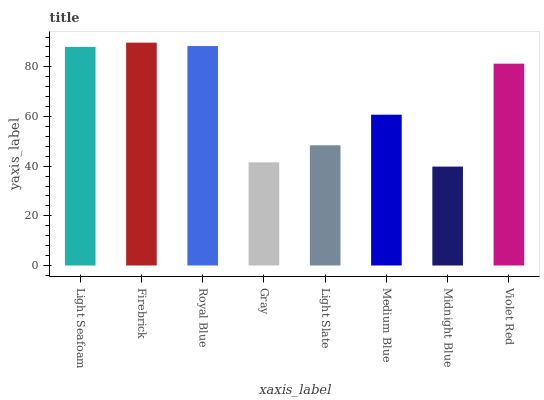Is Midnight Blue the minimum?
Answer yes or no. Yes. Is Firebrick the maximum?
Answer yes or no. Yes. Is Royal Blue the minimum?
Answer yes or no. No. Is Royal Blue the maximum?
Answer yes or no. No. Is Firebrick greater than Royal Blue?
Answer yes or no. Yes. Is Royal Blue less than Firebrick?
Answer yes or no. Yes. Is Royal Blue greater than Firebrick?
Answer yes or no. No. Is Firebrick less than Royal Blue?
Answer yes or no. No. Is Violet Red the high median?
Answer yes or no. Yes. Is Medium Blue the low median?
Answer yes or no. Yes. Is Firebrick the high median?
Answer yes or no. No. Is Firebrick the low median?
Answer yes or no. No. 